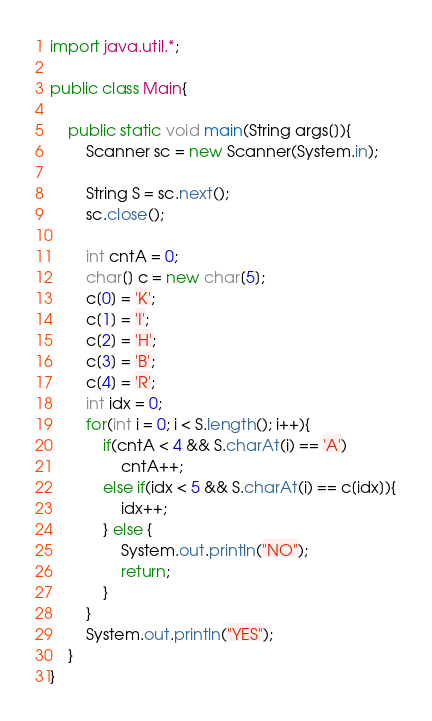Convert code to text. <code><loc_0><loc_0><loc_500><loc_500><_Java_>import java.util.*;

public class Main{

    public static void main(String args[]){
        Scanner sc = new Scanner(System.in);
        
        String S = sc.next();
        sc.close();
    
        int cntA = 0;
        char[] c = new char[5];
        c[0] = 'K';
        c[1] = 'I';
        c[2] = 'H';
        c[3] = 'B';
        c[4] = 'R';
        int idx = 0;
        for(int i = 0; i < S.length(); i++){
            if(cntA < 4 && S.charAt(i) == 'A')
                cntA++;
            else if(idx < 5 && S.charAt(i) == c[idx]){
                idx++;
            } else {
                System.out.println("NO");
                return;
            }
        }
        System.out.println("YES");
    }
}</code> 